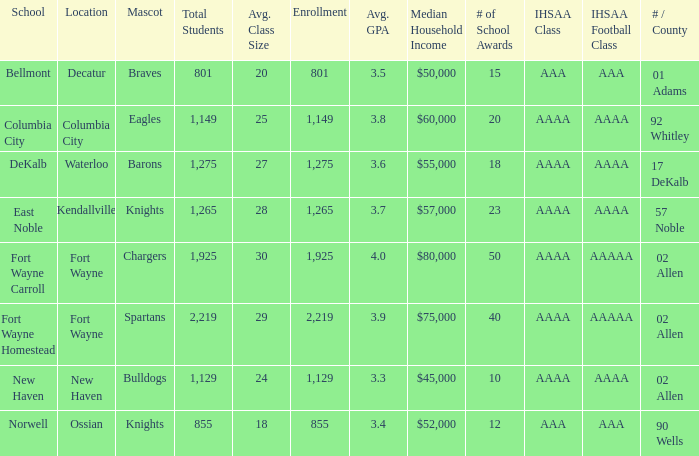What's the IHSAA Football Class in Decatur with an AAA IHSAA class? AAA. 